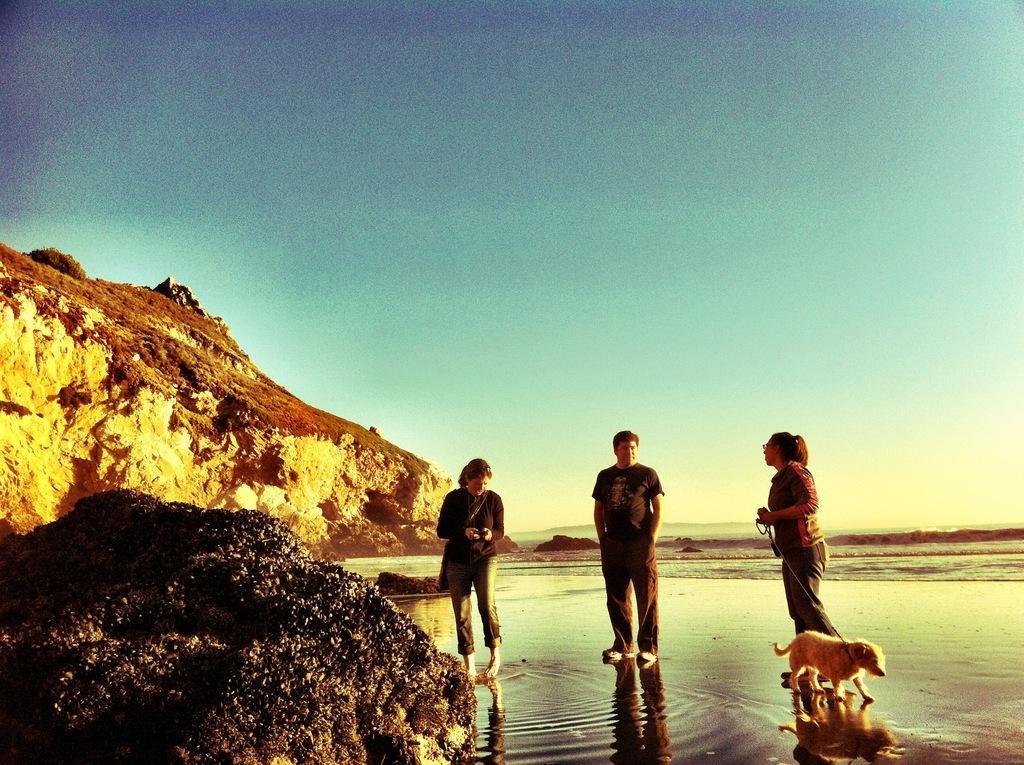In one or two sentences, can you explain what this image depicts? In this image there is a stone in the front and in the center there are persons standing and there is a dog. In the background there is water and there is a mountain. 